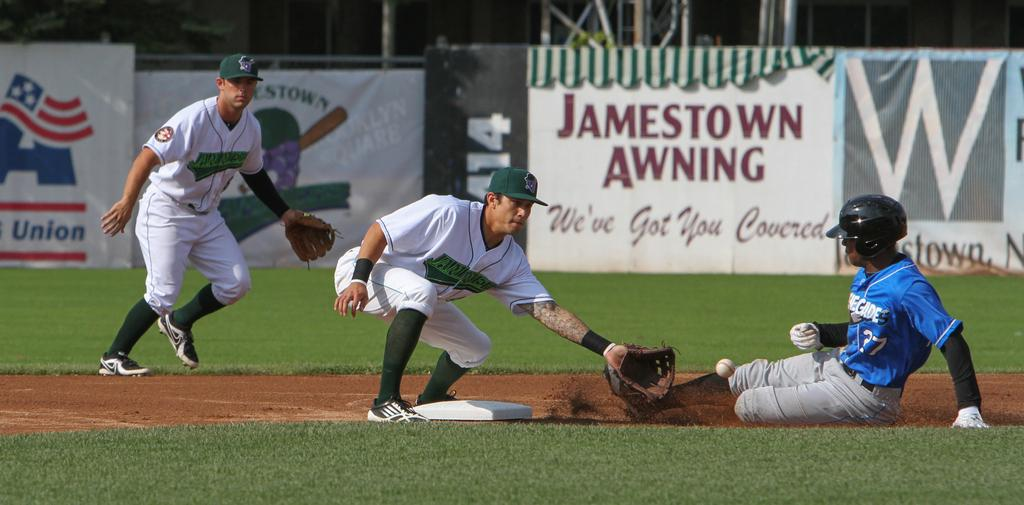<image>
Offer a succinct explanation of the picture presented. Baseball player sliding into second base below a Jamestown Awning sign 